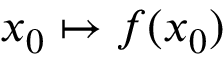Convert formula to latex. <formula><loc_0><loc_0><loc_500><loc_500>x _ { 0 } \mapsto f ( x _ { 0 } )</formula> 